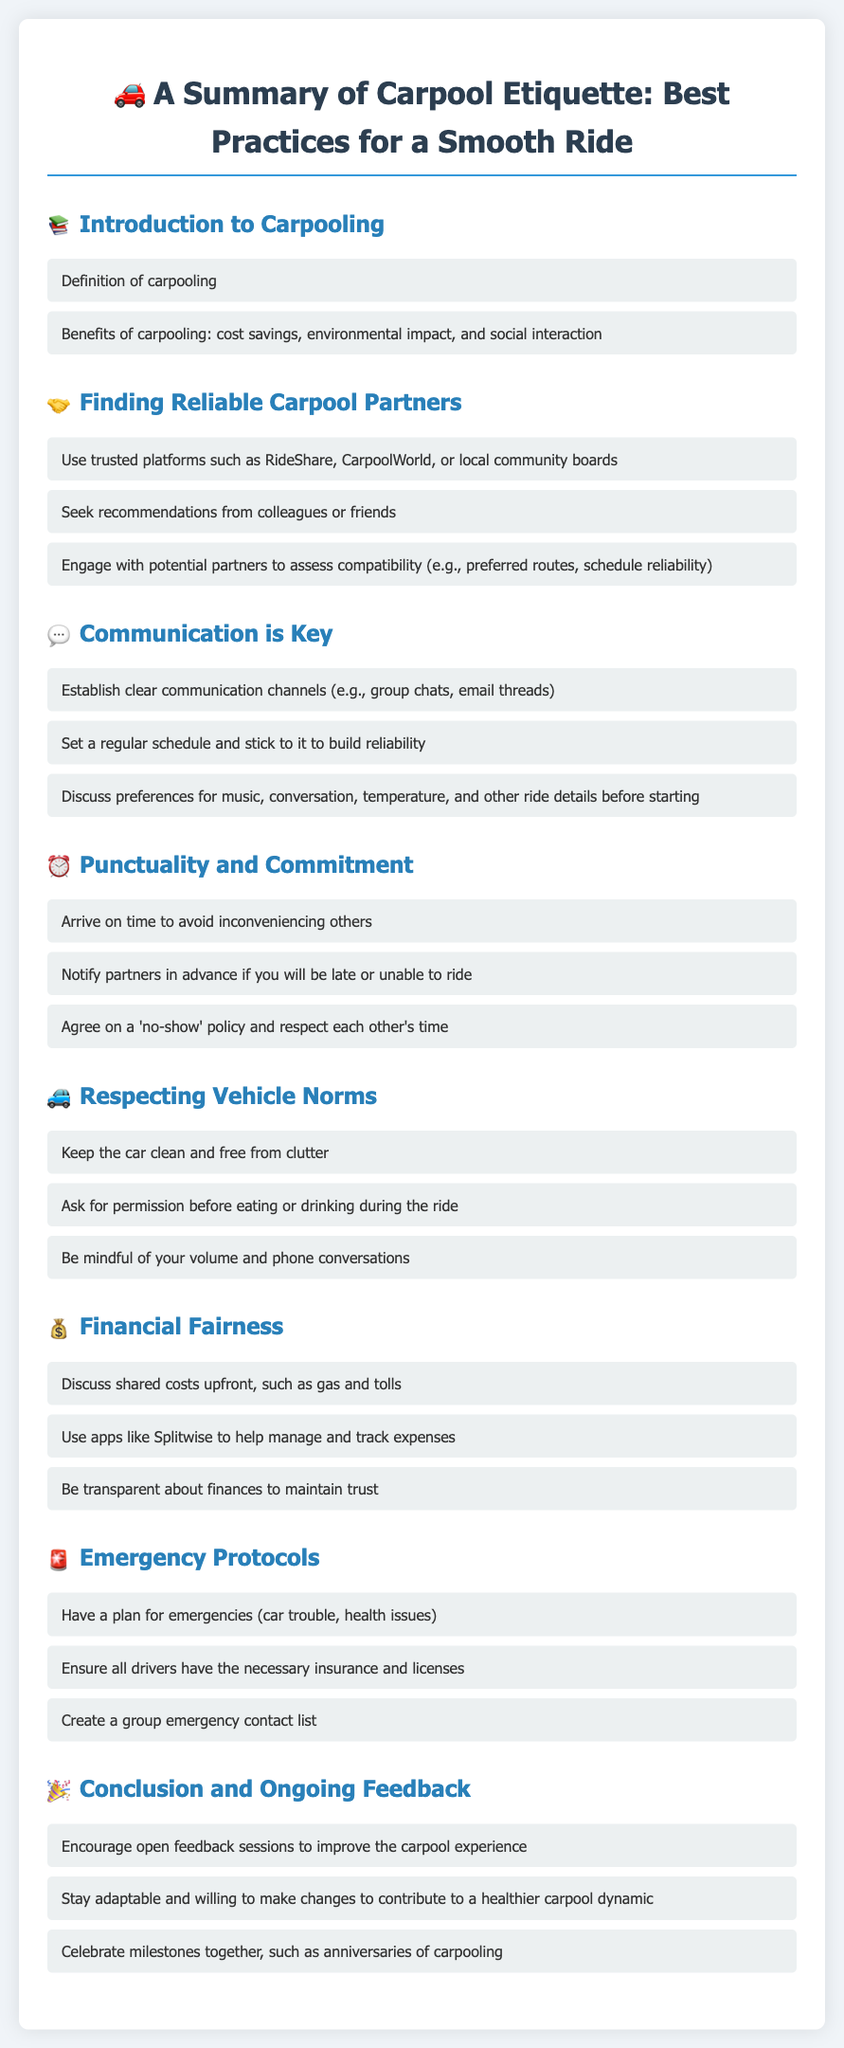What is the main topic of the document? The document is centered around the etiquette and best practices for carpooling, summarizing various aspects to ensure a smooth ride.
Answer: Carpool Etiquette What are two benefits of carpooling? The document lists cost savings and environmental impact among the benefits of carpooling.
Answer: Cost savings, Environmental impact What does the section on communication emphasize? The document highlights the importance of establishing clear communication channels and discussing preferences among carpool partners.
Answer: Communication is Key What should you do if you will be late? According to the document, you should notify your carpool partners in advance if you are running late.
Answer: Notify partners in advance What is suggested to manage shared costs? The document recommends using apps like Splitwise to track and manage shared expenses related to carpooling.
Answer: Splitwise How should the car be maintained during carpooling? The document advises keeping the car clean and free from clutter as part of respecting vehicle norms.
Answer: Clean and free from clutter What should you have a plan for in emergencies? The document suggests having a plan for emergencies such as car trouble or health issues.
Answer: Emergencies What type of feedback should be encouraged continuously? The document encourages ongoing feedback sessions to improve the overall carpool experience.
Answer: Open feedback sessions Who can you seek recommendations from when finding partners? According to the document, recommendations can be sought from colleagues or friends when looking for reliable carpool partners.
Answer: Colleagues or friends 